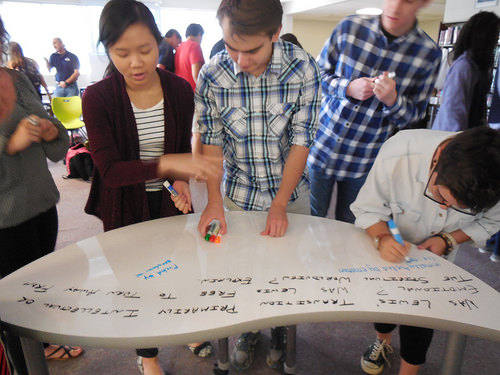<image>
Is there a man on the woman? No. The man is not positioned on the woman. They may be near each other, but the man is not supported by or resting on top of the woman. 